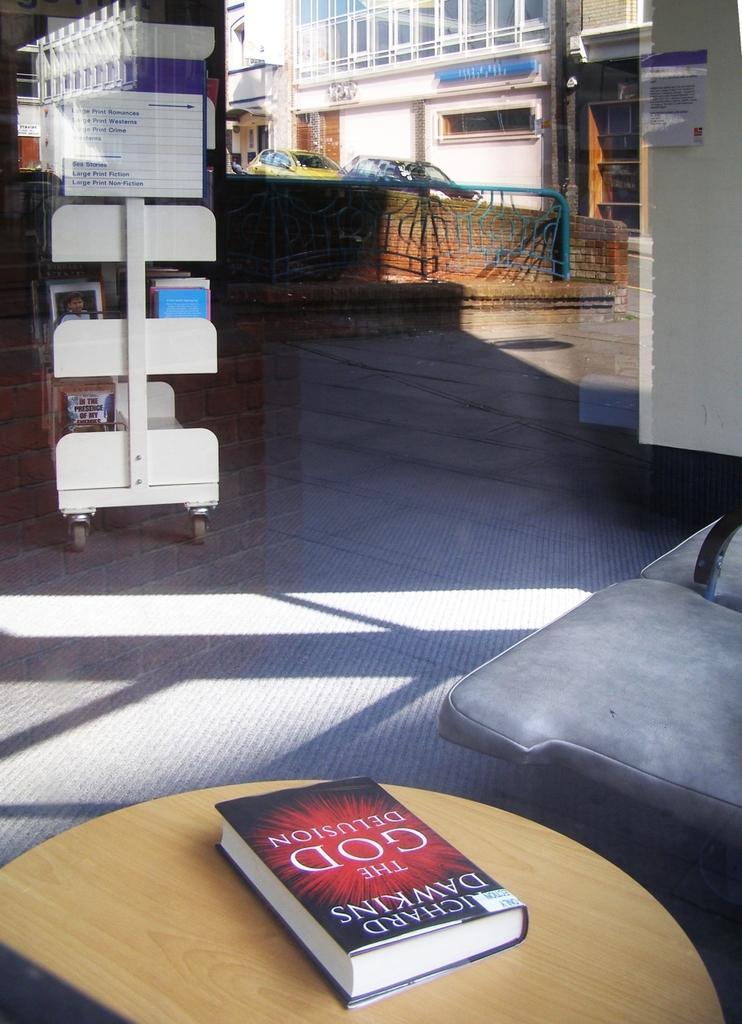Could you give a brief overview of what you see in this image? in this picture we can see a book on the table, and at side their is the chair ,and here there is the books rack ,and at here there are cars ,and here is the building. 